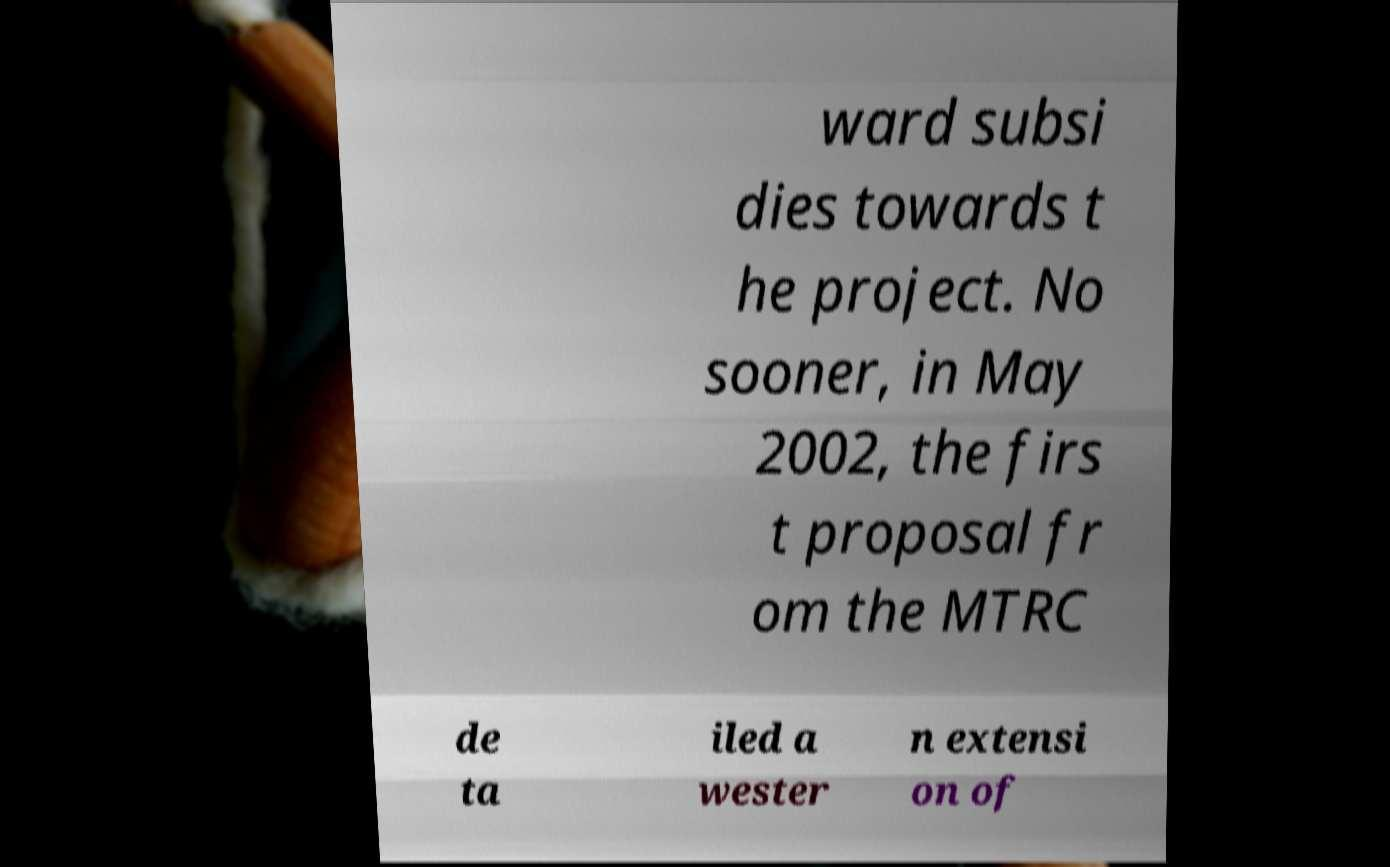What messages or text are displayed in this image? I need them in a readable, typed format. ward subsi dies towards t he project. No sooner, in May 2002, the firs t proposal fr om the MTRC de ta iled a wester n extensi on of 